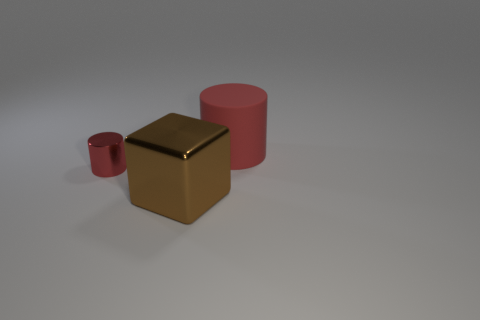There is a tiny object; is it the same color as the big object that is on the left side of the large red thing?
Make the answer very short. No. How many other objects are there of the same size as the brown metal thing?
Make the answer very short. 1. What is the size of the thing that is the same color as the large cylinder?
Offer a terse response. Small. How many cylinders are either tiny gray metallic objects or red metal objects?
Ensure brevity in your answer.  1. There is a red object that is on the left side of the big cylinder; does it have the same shape as the brown metal thing?
Offer a very short reply. No. Is the number of red rubber cylinders that are on the right side of the tiny red thing greater than the number of tiny yellow rubber cubes?
Make the answer very short. Yes. The cylinder that is the same size as the brown object is what color?
Provide a short and direct response. Red. What number of things are large things that are in front of the matte thing or tiny yellow rubber cubes?
Provide a short and direct response. 1. There is a red cylinder in front of the big object behind the big metal thing; what is it made of?
Ensure brevity in your answer.  Metal. Is there a small thing that has the same material as the big brown thing?
Make the answer very short. Yes. 